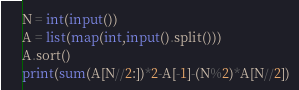Convert code to text. <code><loc_0><loc_0><loc_500><loc_500><_Python_>N = int(input())
A = list(map(int,input().split()))
A.sort()
print(sum(A[N//2:])*2-A[-1]-(N%2)*A[N//2])</code> 